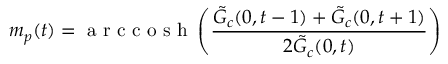<formula> <loc_0><loc_0><loc_500><loc_500>m _ { p } ( t ) = a r c c o s h \left ( \frac { \tilde { G } _ { c } ( 0 , t - 1 ) + \tilde { G } _ { c } ( 0 , t + 1 ) } { 2 \tilde { G } _ { c } ( 0 , t ) } \right )</formula> 